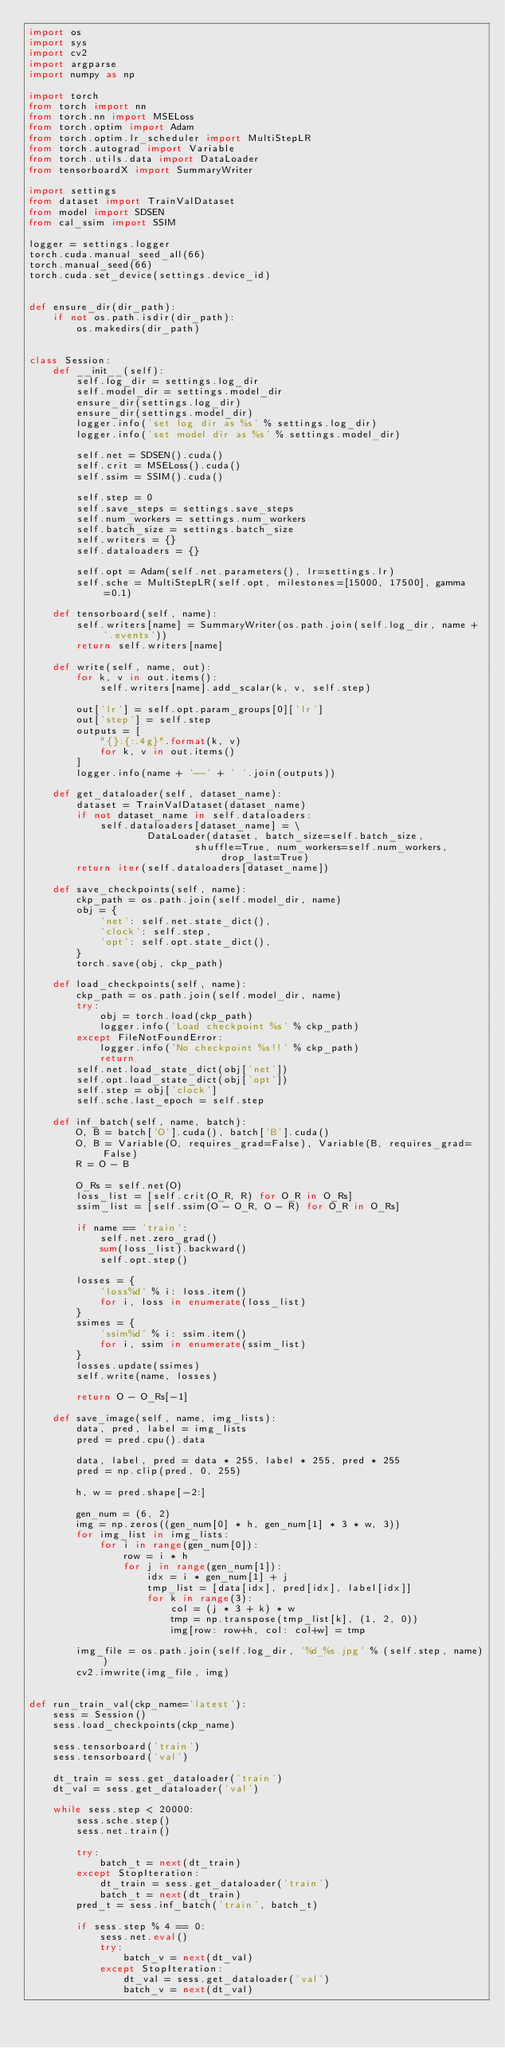<code> <loc_0><loc_0><loc_500><loc_500><_Python_>import os
import sys
import cv2
import argparse
import numpy as np

import torch
from torch import nn
from torch.nn import MSELoss
from torch.optim import Adam
from torch.optim.lr_scheduler import MultiStepLR
from torch.autograd import Variable
from torch.utils.data import DataLoader
from tensorboardX import SummaryWriter

import settings
from dataset import TrainValDataset
from model import SDSEN
from cal_ssim import SSIM

logger = settings.logger
torch.cuda.manual_seed_all(66)
torch.manual_seed(66)
torch.cuda.set_device(settings.device_id)


def ensure_dir(dir_path):
    if not os.path.isdir(dir_path):
        os.makedirs(dir_path)
        

class Session:
    def __init__(self):
        self.log_dir = settings.log_dir
        self.model_dir = settings.model_dir
        ensure_dir(settings.log_dir)
        ensure_dir(settings.model_dir)
        logger.info('set log dir as %s' % settings.log_dir)
        logger.info('set model dir as %s' % settings.model_dir)

        self.net = SDSEN().cuda()
        self.crit = MSELoss().cuda()
        self.ssim = SSIM().cuda()

        self.step = 0
        self.save_steps = settings.save_steps
        self.num_workers = settings.num_workers
        self.batch_size = settings.batch_size
        self.writers = {}
        self.dataloaders = {}

        self.opt = Adam(self.net.parameters(), lr=settings.lr)
        self.sche = MultiStepLR(self.opt, milestones=[15000, 17500], gamma=0.1)

    def tensorboard(self, name):
        self.writers[name] = SummaryWriter(os.path.join(self.log_dir, name + '.events'))
        return self.writers[name]

    def write(self, name, out):
        for k, v in out.items():
            self.writers[name].add_scalar(k, v, self.step)

        out['lr'] = self.opt.param_groups[0]['lr']
        out['step'] = self.step
        outputs = [
            "{}:{:.4g}".format(k, v) 
            for k, v in out.items()
        ]
        logger.info(name + '--' + ' '.join(outputs))

    def get_dataloader(self, dataset_name):
        dataset = TrainValDataset(dataset_name)
        if not dataset_name in self.dataloaders:
            self.dataloaders[dataset_name] = \
                    DataLoader(dataset, batch_size=self.batch_size, 
                            shuffle=True, num_workers=self.num_workers, drop_last=True)
        return iter(self.dataloaders[dataset_name])

    def save_checkpoints(self, name):
        ckp_path = os.path.join(self.model_dir, name)
        obj = {
            'net': self.net.state_dict(),
            'clock': self.step,
            'opt': self.opt.state_dict(),
        }
        torch.save(obj, ckp_path)

    def load_checkpoints(self, name):
        ckp_path = os.path.join(self.model_dir, name)
        try:
            obj = torch.load(ckp_path)
            logger.info('Load checkpoint %s' % ckp_path)
        except FileNotFoundError:
            logger.info('No checkpoint %s!!' % ckp_path)
            return
        self.net.load_state_dict(obj['net'])
        self.opt.load_state_dict(obj['opt'])
        self.step = obj['clock']
        self.sche.last_epoch = self.step

    def inf_batch(self, name, batch):
        O, B = batch['O'].cuda(), batch['B'].cuda()
        O, B = Variable(O, requires_grad=False), Variable(B, requires_grad=False)
        R = O - B

        O_Rs = self.net(O)
        loss_list = [self.crit(O_R, R) for O_R in O_Rs]
        ssim_list = [self.ssim(O - O_R, O - R) for O_R in O_Rs]

        if name == 'train':
            self.net.zero_grad()
            sum(loss_list).backward()
            self.opt.step()

        losses = {
            'loss%d' % i: loss.item()
            for i, loss in enumerate(loss_list)
        }
        ssimes = {
            'ssim%d' % i: ssim.item()
            for i, ssim in enumerate(ssim_list)
        }
        losses.update(ssimes)
        self.write(name, losses)

        return O - O_Rs[-1]

    def save_image(self, name, img_lists):
        data, pred, label = img_lists
        pred = pred.cpu().data

        data, label, pred = data * 255, label * 255, pred * 255
        pred = np.clip(pred, 0, 255)

        h, w = pred.shape[-2:]

        gen_num = (6, 2)
        img = np.zeros((gen_num[0] * h, gen_num[1] * 3 * w, 3))
        for img_list in img_lists:
            for i in range(gen_num[0]):
                row = i * h
                for j in range(gen_num[1]):
                    idx = i * gen_num[1] + j
                    tmp_list = [data[idx], pred[idx], label[idx]]
                    for k in range(3):
                        col = (j * 3 + k) * w
                        tmp = np.transpose(tmp_list[k], (1, 2, 0))
                        img[row: row+h, col: col+w] = tmp 

        img_file = os.path.join(self.log_dir, '%d_%s.jpg' % (self.step, name))
        cv2.imwrite(img_file, img)


def run_train_val(ckp_name='latest'):
    sess = Session()
    sess.load_checkpoints(ckp_name)

    sess.tensorboard('train')
    sess.tensorboard('val')

    dt_train = sess.get_dataloader('train')
    dt_val = sess.get_dataloader('val')

    while sess.step < 20000:
        sess.sche.step()
        sess.net.train()

        try:
            batch_t = next(dt_train)
        except StopIteration:
            dt_train = sess.get_dataloader('train')
            batch_t = next(dt_train)
        pred_t = sess.inf_batch('train', batch_t)

        if sess.step % 4 == 0:
            sess.net.eval()
            try:
                batch_v = next(dt_val)
            except StopIteration:
                dt_val = sess.get_dataloader('val')
                batch_v = next(dt_val)</code> 